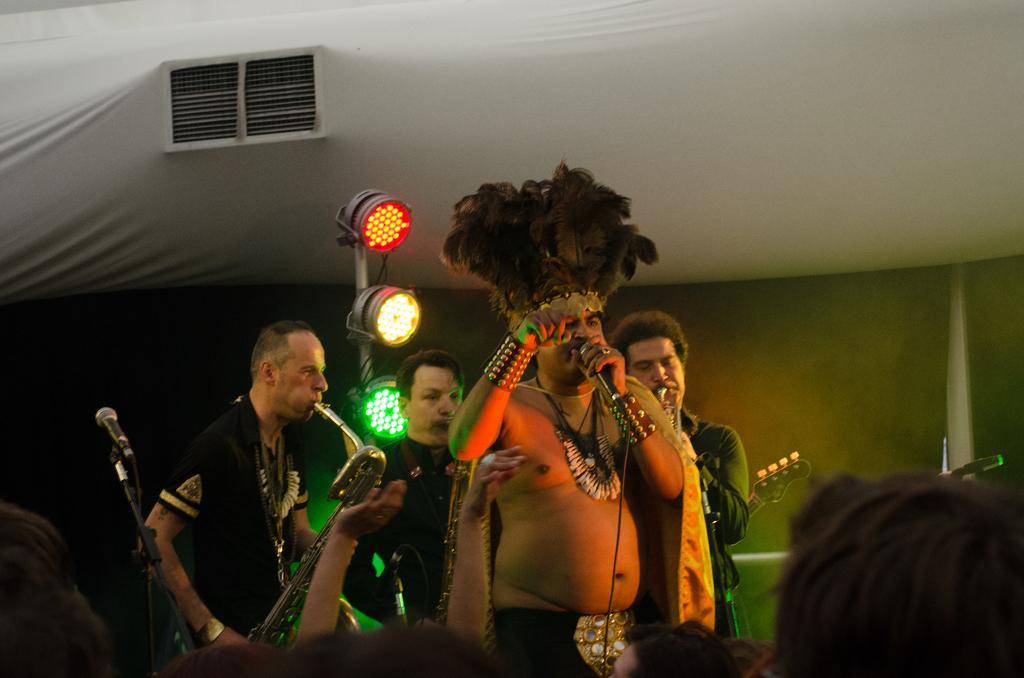Please provide a concise description of this image. In the picture we can see four men, one man is singing and another man is playing a musical instruments and other two are also playing a musical instruments, in t he background we can see three lights on the stand one is red, yellow and green in color, and we can also see some micro phone on the stand, in the background we can see a curtain, a tent, to the tent there is a window. 